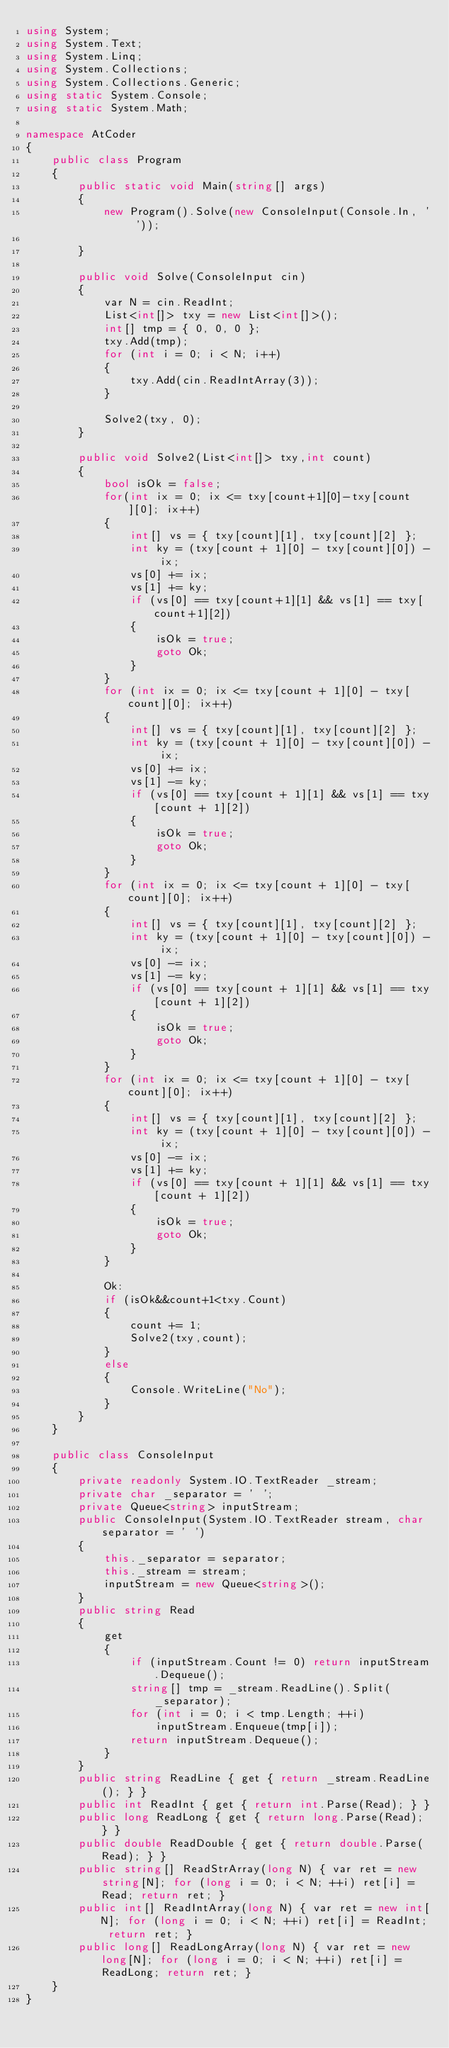<code> <loc_0><loc_0><loc_500><loc_500><_C#_>using System;
using System.Text;
using System.Linq;
using System.Collections;
using System.Collections.Generic;
using static System.Console;
using static System.Math;

namespace AtCoder
{
    public class Program
    {
        public static void Main(string[] args)
        {
            new Program().Solve(new ConsoleInput(Console.In, ' '));

        }

        public void Solve(ConsoleInput cin)
        {
            var N = cin.ReadInt;
            List<int[]> txy = new List<int[]>();
            int[] tmp = { 0, 0, 0 };
            txy.Add(tmp);
            for (int i = 0; i < N; i++)
            {
                txy.Add(cin.ReadIntArray(3));
            }

            Solve2(txy, 0);
        }

        public void Solve2(List<int[]> txy,int count)
        {
            bool isOk = false;
            for(int ix = 0; ix <= txy[count+1][0]-txy[count][0]; ix++)
            {
                int[] vs = { txy[count][1], txy[count][2] };
                int ky = (txy[count + 1][0] - txy[count][0]) - ix;
                vs[0] += ix;
                vs[1] += ky;
                if (vs[0] == txy[count+1][1] && vs[1] == txy[count+1][2])
                {
                    isOk = true;
                    goto Ok;
                }
            }
            for (int ix = 0; ix <= txy[count + 1][0] - txy[count][0]; ix++)
            {
                int[] vs = { txy[count][1], txy[count][2] };
                int ky = (txy[count + 1][0] - txy[count][0]) - ix;
                vs[0] += ix;
                vs[1] -= ky;
                if (vs[0] == txy[count + 1][1] && vs[1] == txy[count + 1][2])
                {
                    isOk = true;
                    goto Ok;
                }
            }
            for (int ix = 0; ix <= txy[count + 1][0] - txy[count][0]; ix++)
            {
                int[] vs = { txy[count][1], txy[count][2] };
                int ky = (txy[count + 1][0] - txy[count][0]) - ix;
                vs[0] -= ix;
                vs[1] -= ky;
                if (vs[0] == txy[count + 1][1] && vs[1] == txy[count + 1][2])
                {
                    isOk = true;
                    goto Ok;
                }
            }
            for (int ix = 0; ix <= txy[count + 1][0] - txy[count][0]; ix++)
            {
                int[] vs = { txy[count][1], txy[count][2] };
                int ky = (txy[count + 1][0] - txy[count][0]) - ix;
                vs[0] -= ix;
                vs[1] += ky;
                if (vs[0] == txy[count + 1][1] && vs[1] == txy[count + 1][2])
                {
                    isOk = true;
                    goto Ok;
                }
            }

            Ok:
            if (isOk&&count+1<txy.Count)
            {
                count += 1;
                Solve2(txy,count);
            }
            else
            {
                Console.WriteLine("No");
            }
        }
    }

    public class ConsoleInput
    {
        private readonly System.IO.TextReader _stream;
        private char _separator = ' ';
        private Queue<string> inputStream;
        public ConsoleInput(System.IO.TextReader stream, char separator = ' ')
        {
            this._separator = separator;
            this._stream = stream;
            inputStream = new Queue<string>();
        }
        public string Read
        {
            get
            {
                if (inputStream.Count != 0) return inputStream.Dequeue();
                string[] tmp = _stream.ReadLine().Split(_separator);
                for (int i = 0; i < tmp.Length; ++i)
                    inputStream.Enqueue(tmp[i]);
                return inputStream.Dequeue();
            }
        }
        public string ReadLine { get { return _stream.ReadLine(); } }
        public int ReadInt { get { return int.Parse(Read); } }
        public long ReadLong { get { return long.Parse(Read); } }
        public double ReadDouble { get { return double.Parse(Read); } }
        public string[] ReadStrArray(long N) { var ret = new string[N]; for (long i = 0; i < N; ++i) ret[i] = Read; return ret; }
        public int[] ReadIntArray(long N) { var ret = new int[N]; for (long i = 0; i < N; ++i) ret[i] = ReadInt; return ret; }
        public long[] ReadLongArray(long N) { var ret = new long[N]; for (long i = 0; i < N; ++i) ret[i] = ReadLong; return ret; }
    }
}</code> 